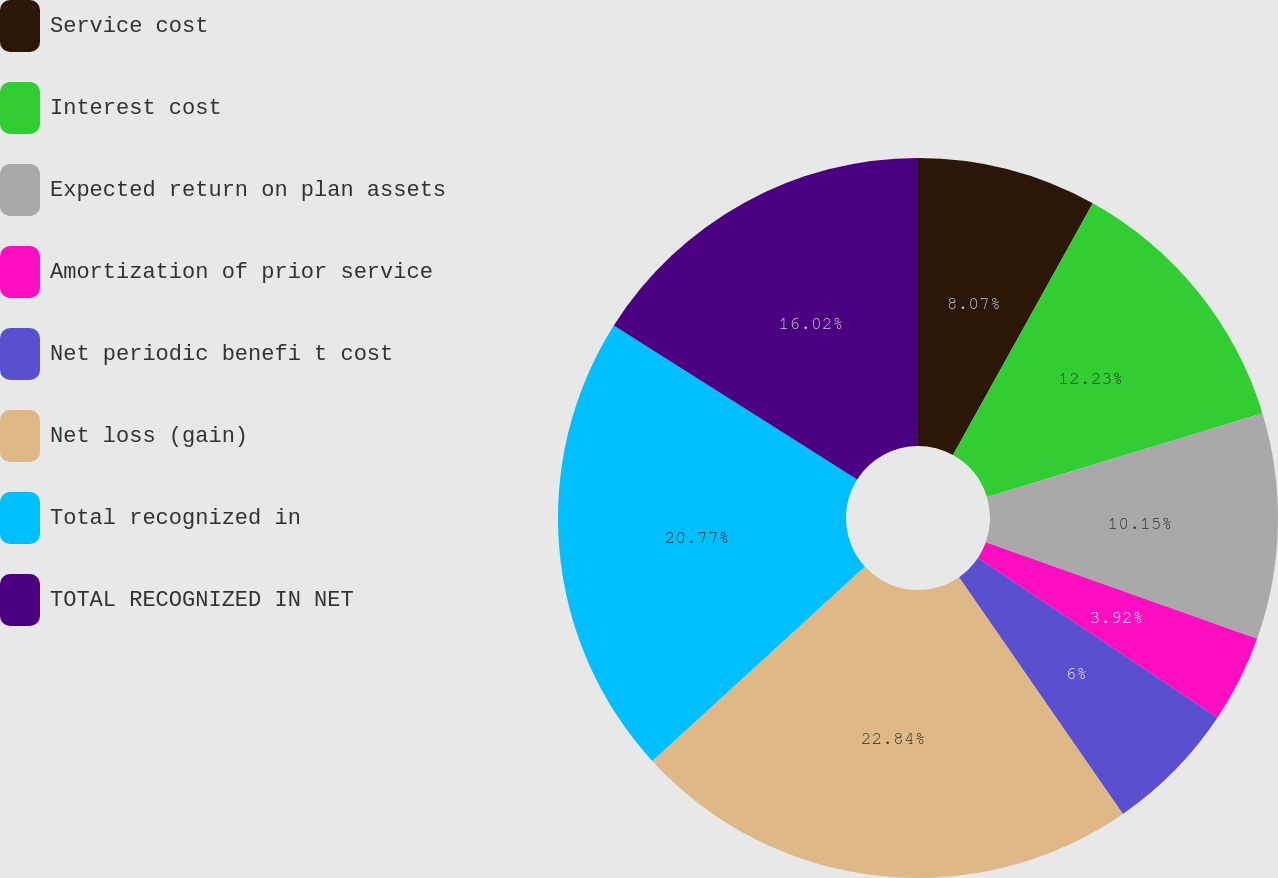Convert chart. <chart><loc_0><loc_0><loc_500><loc_500><pie_chart><fcel>Service cost<fcel>Interest cost<fcel>Expected return on plan assets<fcel>Amortization of prior service<fcel>Net periodic benefi t cost<fcel>Net loss (gain)<fcel>Total recognized in<fcel>TOTAL RECOGNIZED IN NET<nl><fcel>8.07%<fcel>12.23%<fcel>10.15%<fcel>3.92%<fcel>6.0%<fcel>22.85%<fcel>20.77%<fcel>16.02%<nl></chart> 